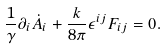Convert formula to latex. <formula><loc_0><loc_0><loc_500><loc_500>\frac { 1 } { \gamma } \partial _ { i } \dot { A } _ { i } + \frac { k } { 8 \pi } \epsilon ^ { i j } F _ { i j } = 0 .</formula> 